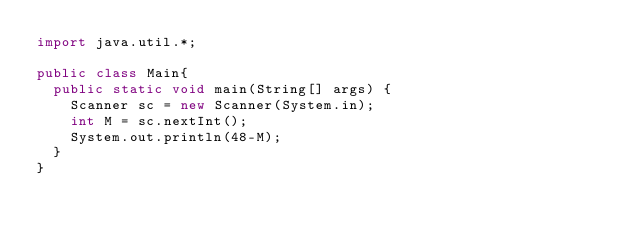Convert code to text. <code><loc_0><loc_0><loc_500><loc_500><_Java_>import java.util.*;

public class Main{
  public static void main(String[] args) {
    Scanner sc = new Scanner(System.in);
    int M = sc.nextInt();
    System.out.println(48-M);
  }
}</code> 